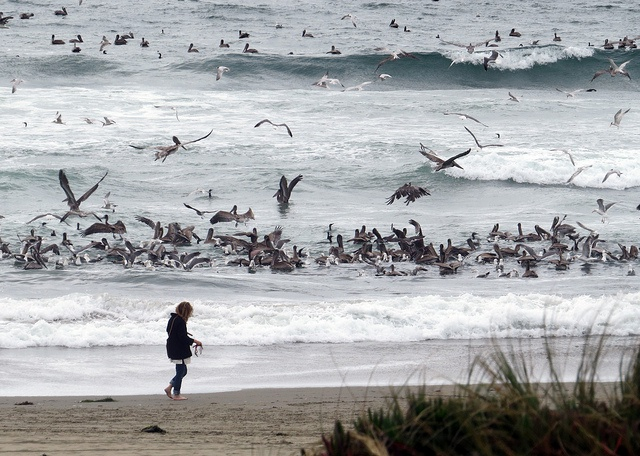Describe the objects in this image and their specific colors. I can see bird in darkgray, lightgray, and gray tones, people in darkgray, black, gray, and lightgray tones, bird in darkgray, gray, and black tones, bird in darkgray, black, and gray tones, and bird in darkgray, gray, black, and lightgray tones in this image. 